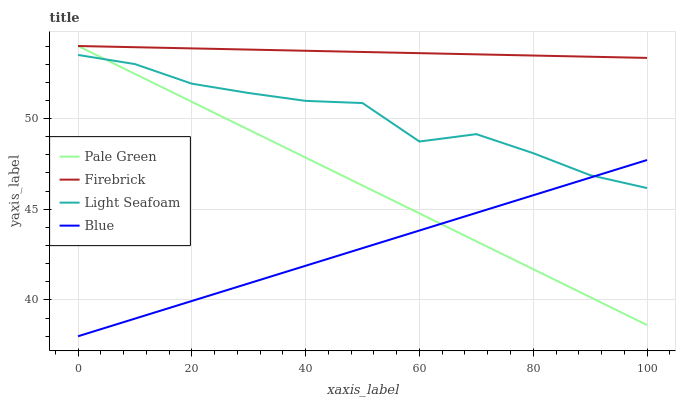Does Blue have the minimum area under the curve?
Answer yes or no. Yes. Does Firebrick have the maximum area under the curve?
Answer yes or no. Yes. Does Pale Green have the minimum area under the curve?
Answer yes or no. No. Does Pale Green have the maximum area under the curve?
Answer yes or no. No. Is Blue the smoothest?
Answer yes or no. Yes. Is Light Seafoam the roughest?
Answer yes or no. Yes. Is Firebrick the smoothest?
Answer yes or no. No. Is Firebrick the roughest?
Answer yes or no. No. Does Pale Green have the lowest value?
Answer yes or no. No. Does Pale Green have the highest value?
Answer yes or no. Yes. Does Light Seafoam have the highest value?
Answer yes or no. No. Is Blue less than Firebrick?
Answer yes or no. Yes. Is Firebrick greater than Light Seafoam?
Answer yes or no. Yes. Does Blue intersect Pale Green?
Answer yes or no. Yes. Is Blue less than Pale Green?
Answer yes or no. No. Is Blue greater than Pale Green?
Answer yes or no. No. Does Blue intersect Firebrick?
Answer yes or no. No. 